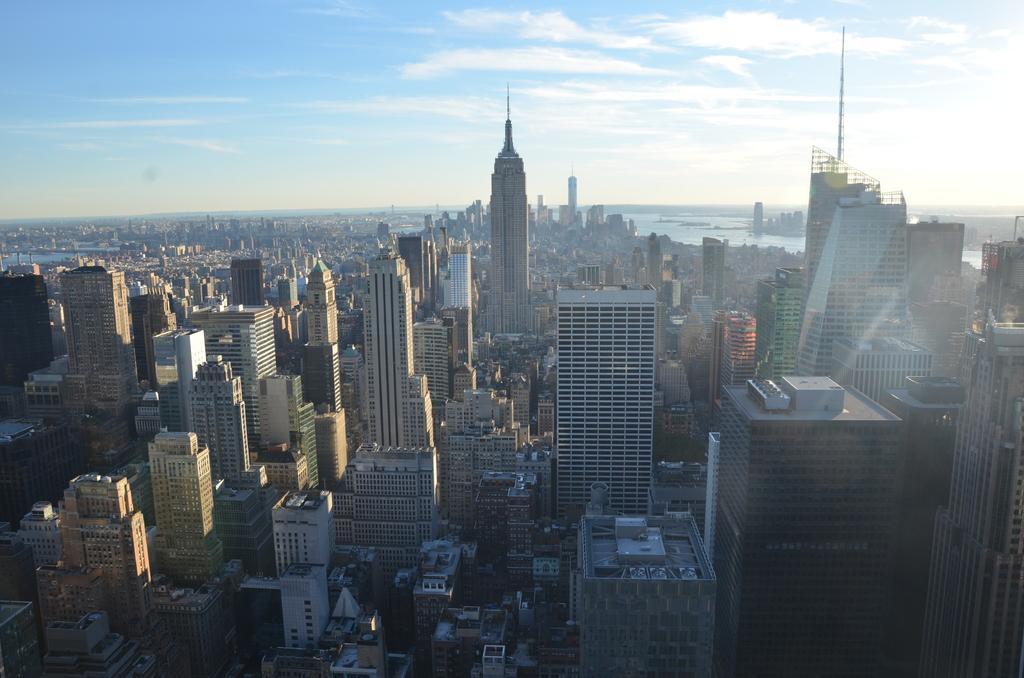Describe this image in one or two sentences. In this image in the center there are buildings, houses and skyscrapers, and in the background there is a sea. And at the top there is sky. 